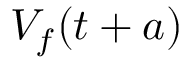Convert formula to latex. <formula><loc_0><loc_0><loc_500><loc_500>V _ { f } ( t + a )</formula> 